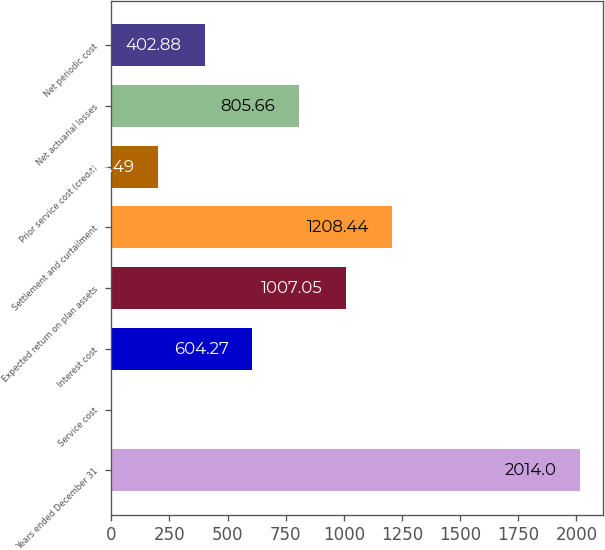Convert chart. <chart><loc_0><loc_0><loc_500><loc_500><bar_chart><fcel>Years ended December 31<fcel>Service cost<fcel>Interest cost<fcel>Expected return on plan assets<fcel>Settlement and curtailment<fcel>Prior service cost (credit)<fcel>Net actuarial losses<fcel>Net periodic cost<nl><fcel>2014<fcel>0.1<fcel>604.27<fcel>1007.05<fcel>1208.44<fcel>201.49<fcel>805.66<fcel>402.88<nl></chart> 